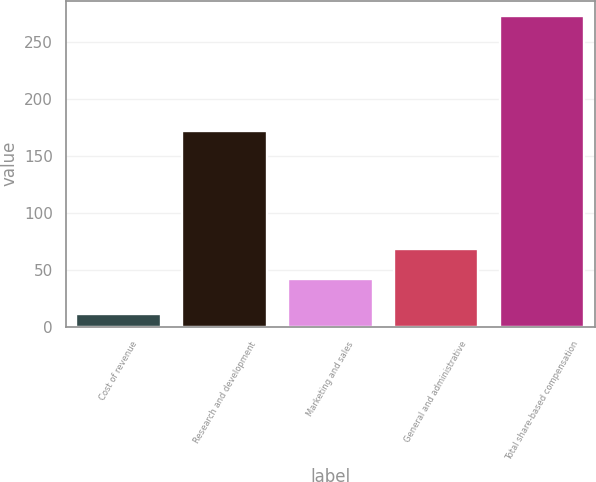<chart> <loc_0><loc_0><loc_500><loc_500><bar_chart><fcel>Cost of revenue<fcel>Research and development<fcel>Marketing and sales<fcel>General and administrative<fcel>Total share-based compensation<nl><fcel>11<fcel>172<fcel>42<fcel>68.2<fcel>273<nl></chart> 